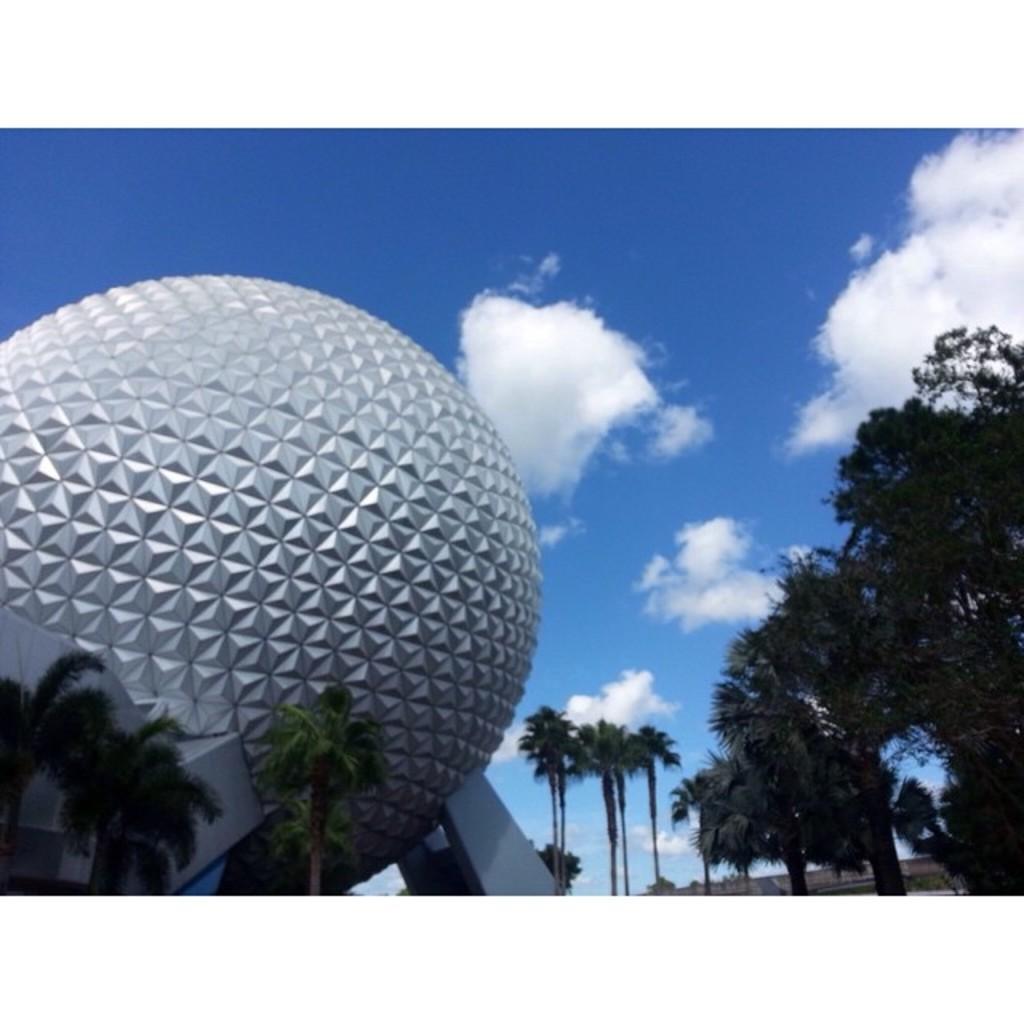Could you give a brief overview of what you see in this image? In the picture we can see a part of a huge golf ball construction near to it, we can see some coconut trees and some other trees and in the background we can see the sky with clouds. 